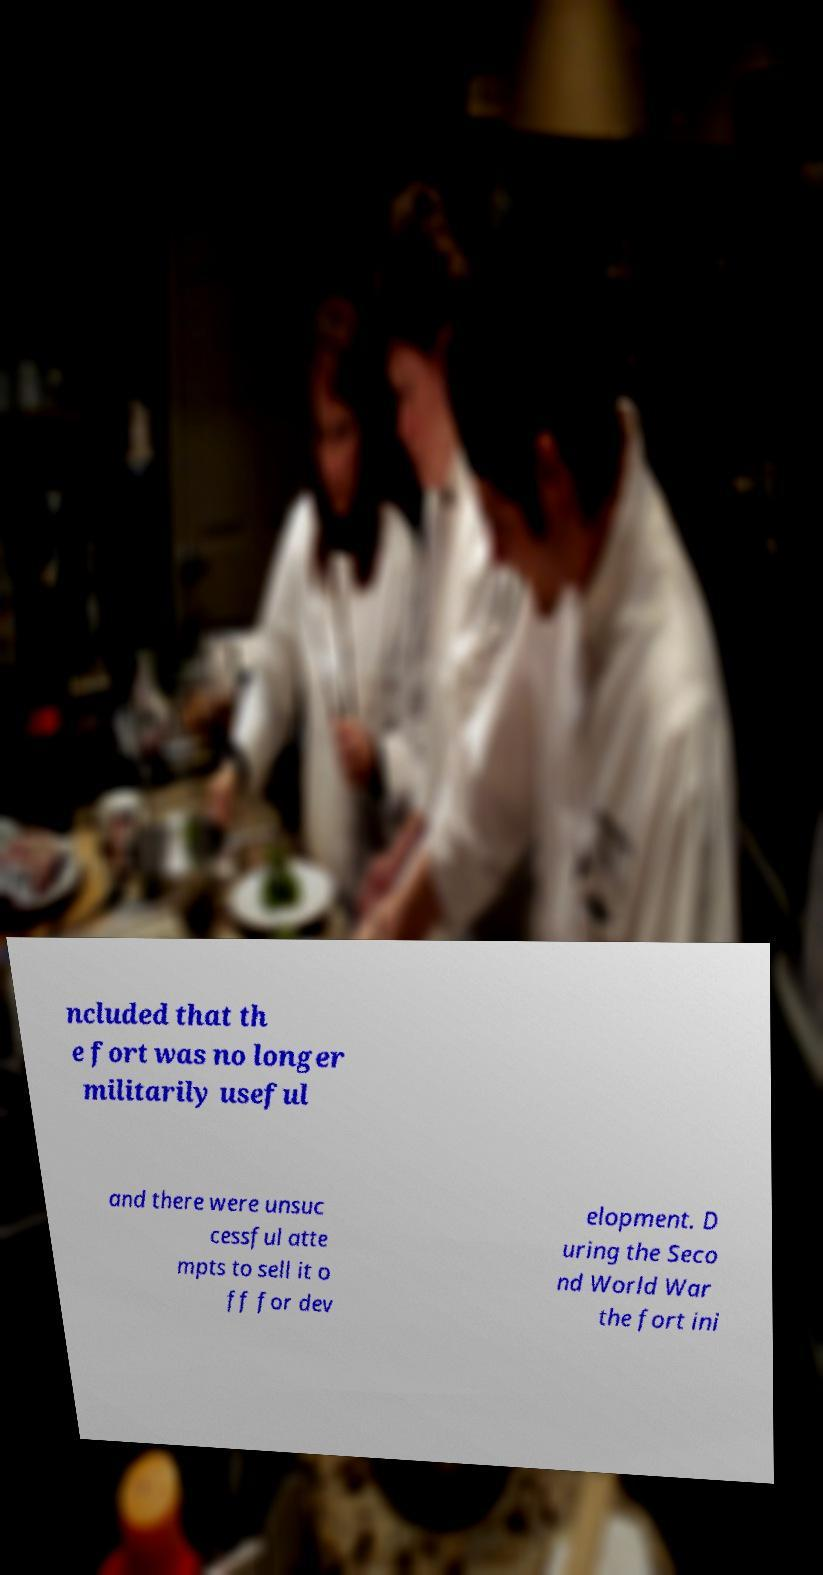Could you extract and type out the text from this image? ncluded that th e fort was no longer militarily useful and there were unsuc cessful atte mpts to sell it o ff for dev elopment. D uring the Seco nd World War the fort ini 